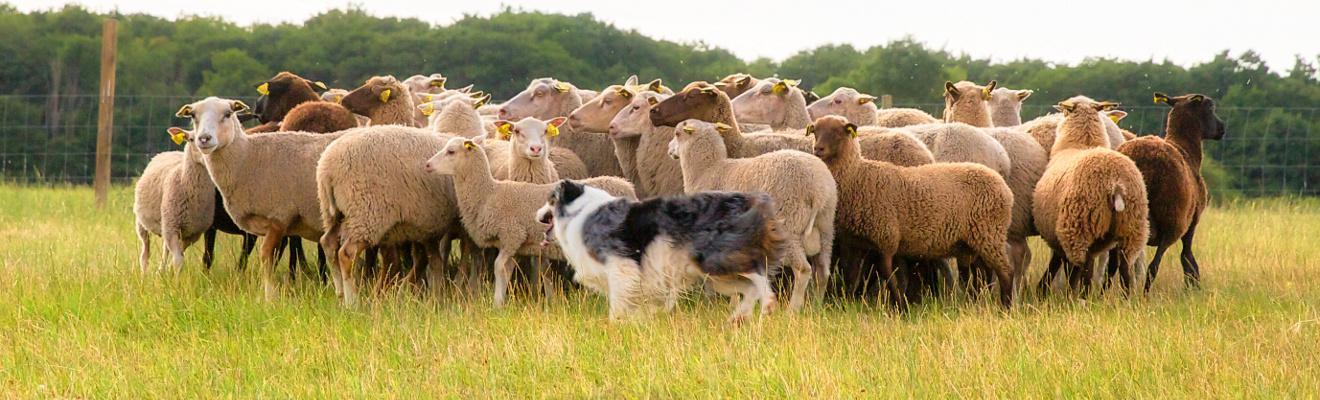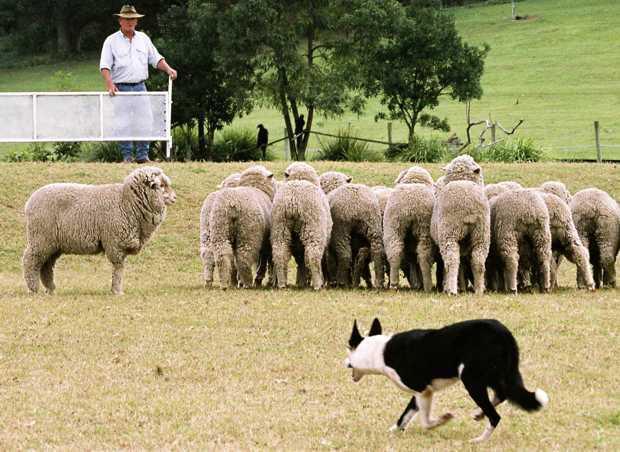The first image is the image on the left, the second image is the image on the right. Assess this claim about the two images: "An image shows a dog behind three sheep which are moving leftward.". Correct or not? Answer yes or no. No. 